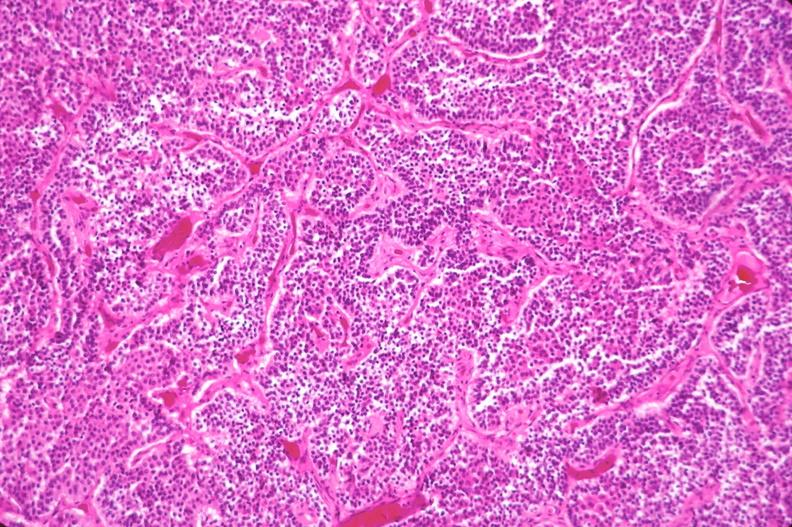s endocrine present?
Answer the question using a single word or phrase. Yes 